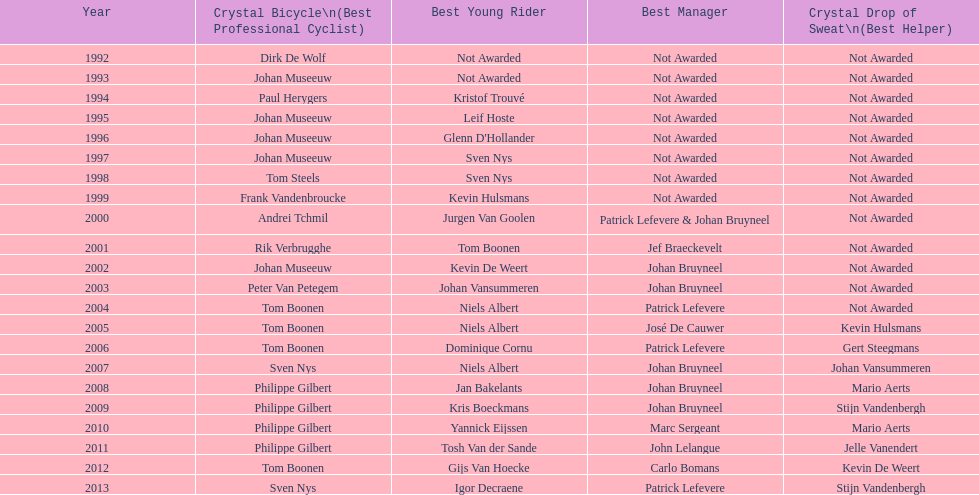How many times does johan bryneel's name show up across all these lists? 6. Would you be able to parse every entry in this table? {'header': ['Year', 'Crystal Bicycle\\n(Best Professional Cyclist)', 'Best Young Rider', 'Best Manager', 'Crystal Drop of Sweat\\n(Best Helper)'], 'rows': [['1992', 'Dirk De Wolf', 'Not Awarded', 'Not Awarded', 'Not Awarded'], ['1993', 'Johan Museeuw', 'Not Awarded', 'Not Awarded', 'Not Awarded'], ['1994', 'Paul Herygers', 'Kristof Trouvé', 'Not Awarded', 'Not Awarded'], ['1995', 'Johan Museeuw', 'Leif Hoste', 'Not Awarded', 'Not Awarded'], ['1996', 'Johan Museeuw', "Glenn D'Hollander", 'Not Awarded', 'Not Awarded'], ['1997', 'Johan Museeuw', 'Sven Nys', 'Not Awarded', 'Not Awarded'], ['1998', 'Tom Steels', 'Sven Nys', 'Not Awarded', 'Not Awarded'], ['1999', 'Frank Vandenbroucke', 'Kevin Hulsmans', 'Not Awarded', 'Not Awarded'], ['2000', 'Andrei Tchmil', 'Jurgen Van Goolen', 'Patrick Lefevere & Johan Bruyneel', 'Not Awarded'], ['2001', 'Rik Verbrugghe', 'Tom Boonen', 'Jef Braeckevelt', 'Not Awarded'], ['2002', 'Johan Museeuw', 'Kevin De Weert', 'Johan Bruyneel', 'Not Awarded'], ['2003', 'Peter Van Petegem', 'Johan Vansummeren', 'Johan Bruyneel', 'Not Awarded'], ['2004', 'Tom Boonen', 'Niels Albert', 'Patrick Lefevere', 'Not Awarded'], ['2005', 'Tom Boonen', 'Niels Albert', 'José De Cauwer', 'Kevin Hulsmans'], ['2006', 'Tom Boonen', 'Dominique Cornu', 'Patrick Lefevere', 'Gert Steegmans'], ['2007', 'Sven Nys', 'Niels Albert', 'Johan Bruyneel', 'Johan Vansummeren'], ['2008', 'Philippe Gilbert', 'Jan Bakelants', 'Johan Bruyneel', 'Mario Aerts'], ['2009', 'Philippe Gilbert', 'Kris Boeckmans', 'Johan Bruyneel', 'Stijn Vandenbergh'], ['2010', 'Philippe Gilbert', 'Yannick Eijssen', 'Marc Sergeant', 'Mario Aerts'], ['2011', 'Philippe Gilbert', 'Tosh Van der Sande', 'John Lelangue', 'Jelle Vanendert'], ['2012', 'Tom Boonen', 'Gijs Van Hoecke', 'Carlo Bomans', 'Kevin De Weert'], ['2013', 'Sven Nys', 'Igor Decraene', 'Patrick Lefevere', 'Stijn Vandenbergh']]} 